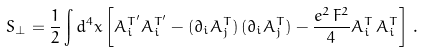<formula> <loc_0><loc_0><loc_500><loc_500>S _ { \perp } = \frac { 1 } { 2 } \int d ^ { 4 } x \left [ A _ { i } ^ { T ^ { \prime } } A _ { i } ^ { T ^ { \prime } } - ( \partial _ { i } A _ { j } ^ { T } ) \, ( \partial _ { i } A _ { j } ^ { T } ) - \frac { e ^ { 2 } \, F ^ { 2 } } { 4 } A _ { i } ^ { T } \, A _ { i } ^ { T } \right ] \, .</formula> 